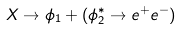<formula> <loc_0><loc_0><loc_500><loc_500>X \rightarrow \phi _ { 1 } + ( \phi ^ { * } _ { 2 } \rightarrow e ^ { + } e ^ { - } )</formula> 